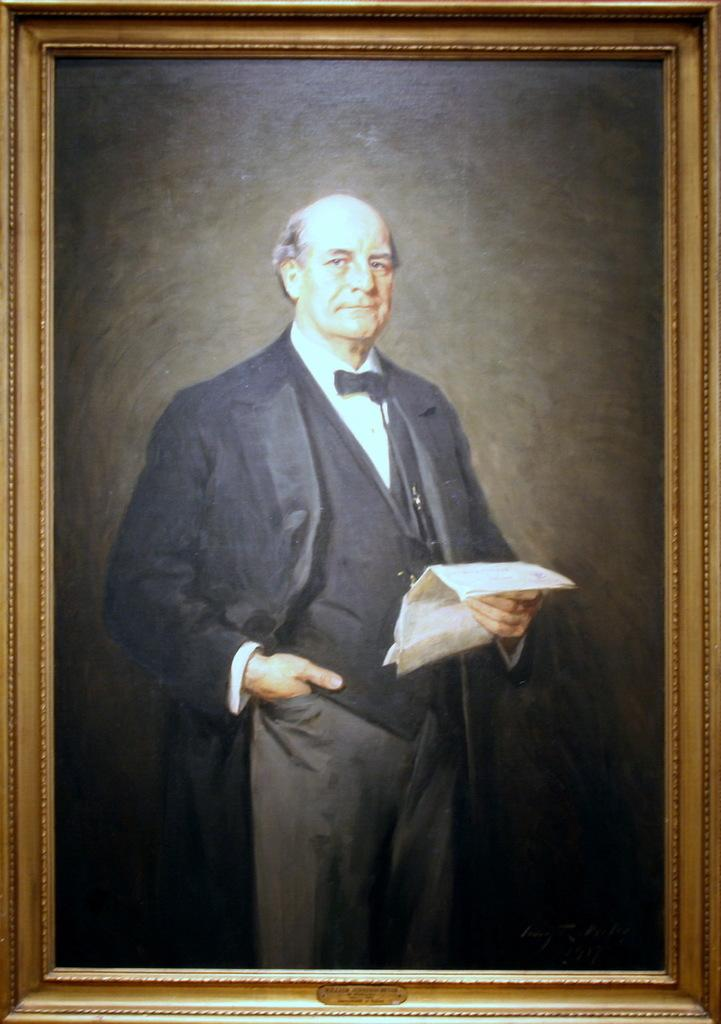What is the main subject of the image? There is a person in the image. What is the person holding in the image? The person is holding a paper. What type of object is the image contained within? The image is a photo frame. Can you see any clouds in the image? There are no clouds visible in the image, as it is a photo frame containing a picture of a person holding a paper. 